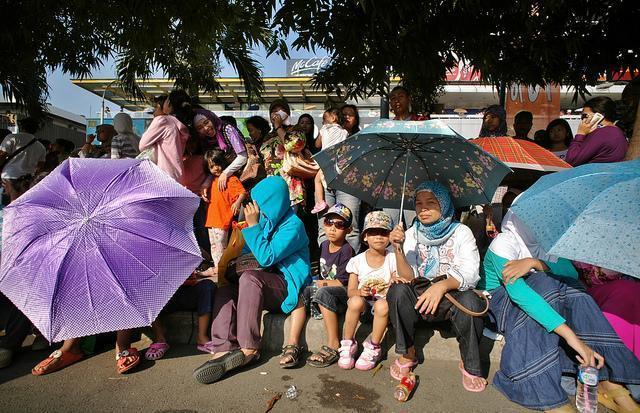How many umbrellas are visible?
Give a very brief answer. 4. How many people are there?
Give a very brief answer. 8. 